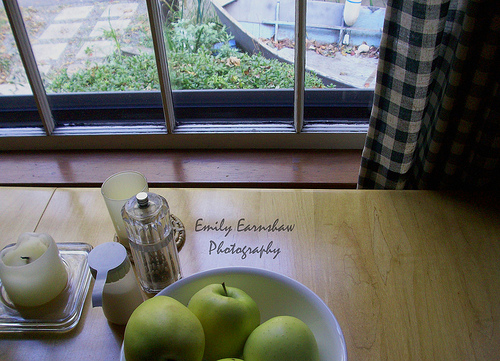<image>
Is the apple in the table? No. The apple is not contained within the table. These objects have a different spatial relationship. Is there a candle on the table? Yes. Looking at the image, I can see the candle is positioned on top of the table, with the table providing support. 